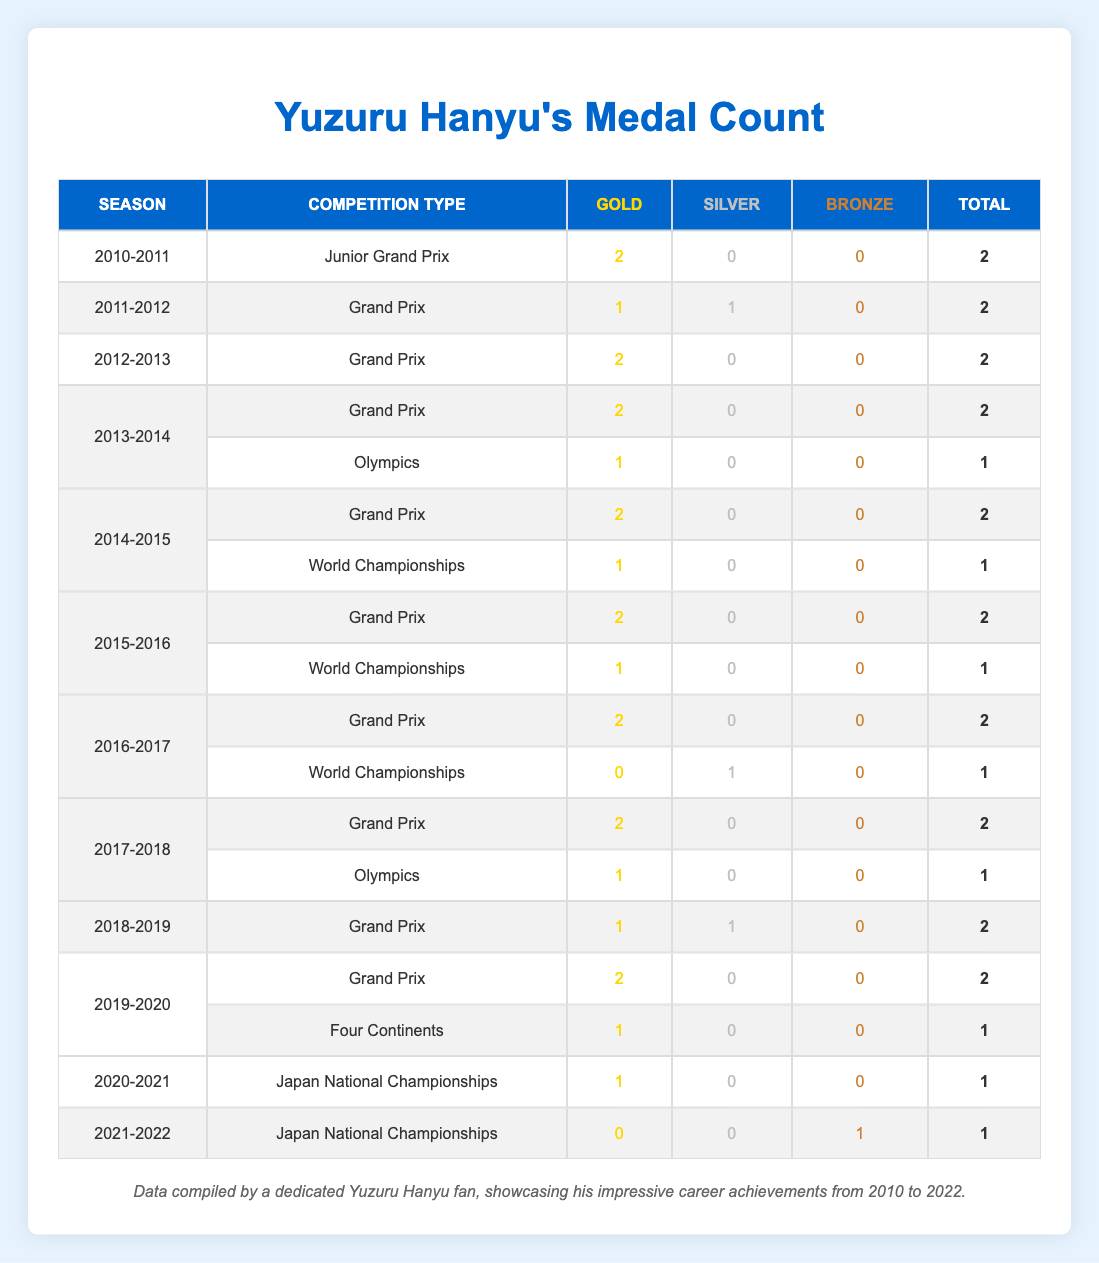What is the total number of gold medals Yuzuru Hanyu won in the 2017-2018 season? In the 2017-2018 season, there are two entries in the table: one for the Grand Prix with 2 gold medals and one for the Olympics with 1 gold medal. Hence, the total is 2 + 1 = 3.
Answer: 3 How many silver medals did Yuzuru Hanyu win over his entire career as listed in the table? By looking through the entire table, Yuzuru Hanyu has the following silver medal counts: 1 (2011-2012), 1 (2016-2017), 1 (2018-2019), and 0 in all other entries. Adding these gives us 1 + 1 + 1 = 3 silver medals in total.
Answer: 3 Did Yuzuru Hanyu ever win a bronze medal at the World Championships? In the table, there is an entry for the 2016-2017 season at the World Championships where he won 1 silver, but no entry shows a bronze medal. Therefore, the answer is no, he did not win a bronze medal at the World Championships.
Answer: No Which competition type did Yuzuru Hanyu win the most gold medals in? Reviewing the table, we can see that he has 2 gold medals from the Junior Grand Prix (2010-2011), 12 gold medals from the Grand Prix across multiple seasons, and 2 from the Olympics (2014 and 2018). Thus, the Grand Prix has the highest count at 12 gold medals.
Answer: Grand Prix What is the average number of total medals (gold, silver, bronze) Yuzuru Hanyu won per season? First, we total all medals. Counting all (gold, silver, bronze) gives us: Gold = 12, Silver = 3, Bronze = 2. Therefore, the total medals = 12 + 3 + 2 = 17. He competed in 13 seasons, so the average is 17 / 13 ≈ 1.31 medals per season.
Answer: 1.31 How many medals did Yuzuru Hanyu win in the 2014-2015 season? Looking at the 2014-2015 entries, he won 2 gold medals in the Grand Prix and 1 gold medal in the World Championships, for a total of 2 + 1 = 3 medals that season.
Answer: 3 In which season did Yuzuru Hanyu achieve a total of 1 bronze medal? The table indicates that in the 2021-2022 season, he won 1 bronze medal in the Japan National Championships, with all other seasons having no bronze medals listed. Thus, the answer is the 2021-2022 season.
Answer: 2021-2022 Was there any season where Yuzuru Hanyu did not win any medals? Analyzing the table, we can see the 2021-2022 season where he only won a bronze medal but no gold or silver. However, every season listed has at least one medal. So the answer is no, there was no season without any medals.
Answer: No 